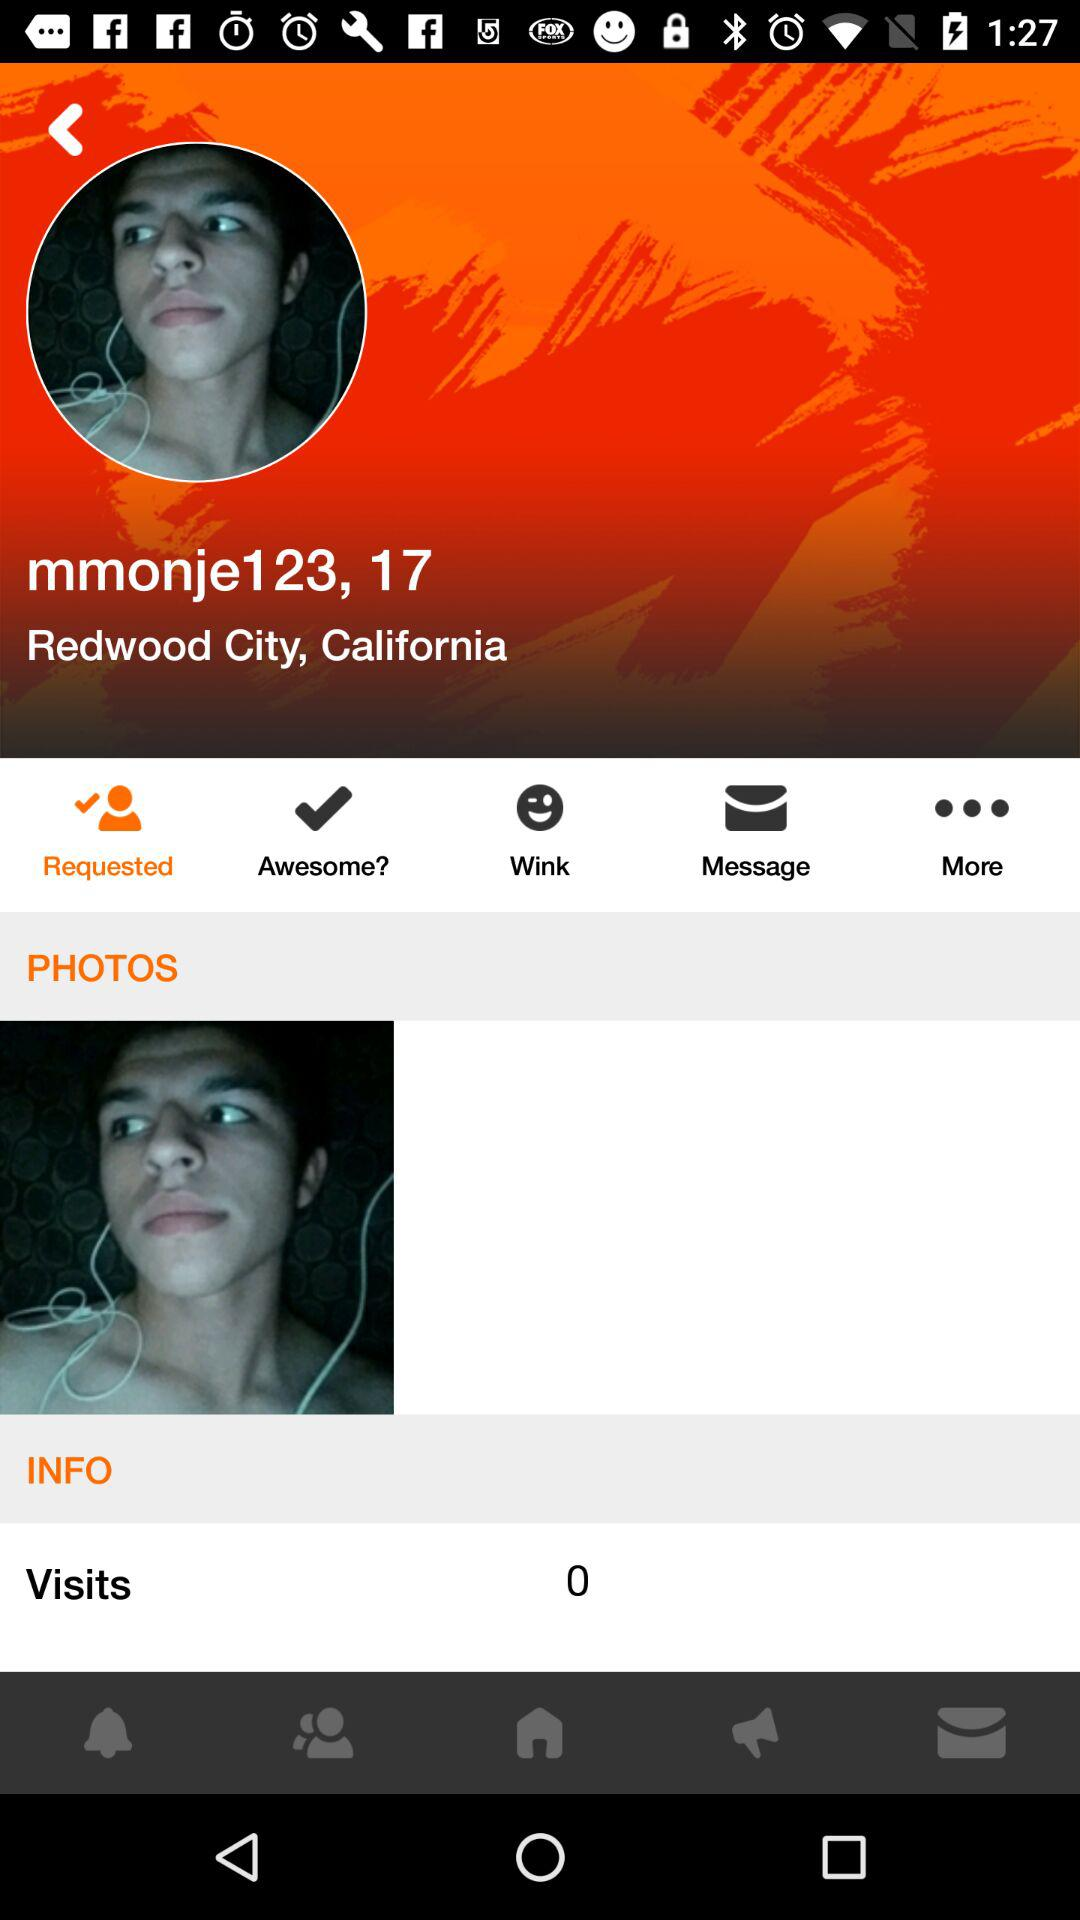What is the total number of visits? The total number of visits is 0. 